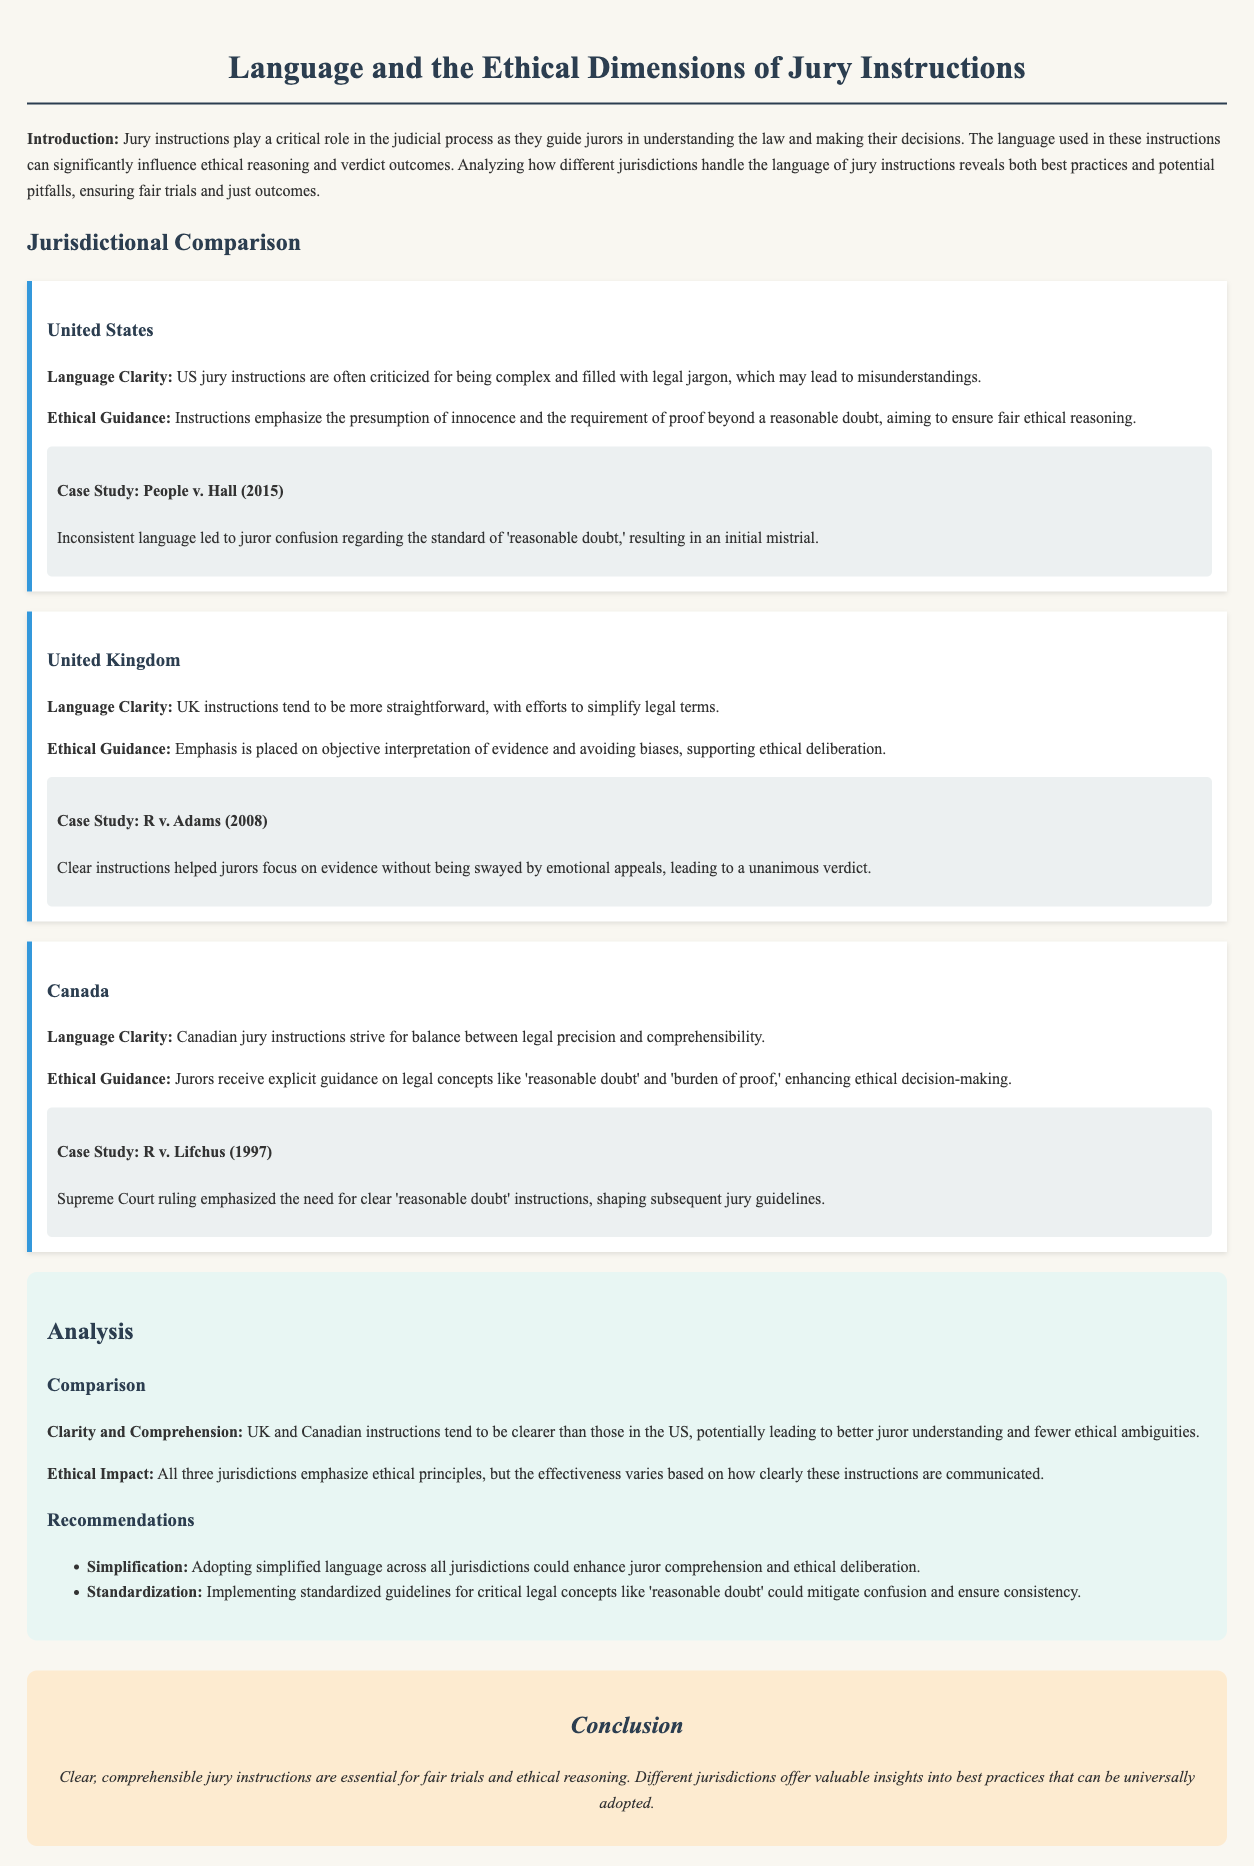what is the primary focus of the document? The document focuses on the influence of language on ethical reasoning through jury instructions across different jurisdictions.
Answer: influence of language on ethical reasoning which case study is related to the United States? The case study that addresses the United States is about People v. Hall in 2015.
Answer: People v. Hall (2015) how do UK jury instructions differ from US instructions in terms of language? UK jury instructions tend to be more straightforward and attempt to simplify legal terms compared to US instructions, which are often complex.
Answer: more straightforward what guidance do Canadian jury instructions provide regarding 'reasonable doubt'? Canadian jury instructions provide explicit guidance on the concept of 'reasonable doubt' to enhance ethical decision-making.
Answer: explicit guidance which recommendation is suggested for improving jury instructions? One of the recommendations is to adopt simplified language across all jurisdictions to enhance comprehension.
Answer: simplified language how does the clarity of jury instructions affect ethical reasoning? The clarity of jury instructions can lead to better juror understanding and fewer ethical ambiguities, impacting the ethical reasoning process.
Answer: better juror understanding which jurisdiction emphasizes the presumption of innocence in jury instructions? The United States emphasizes the presumption of innocence in its jury instructions.
Answer: United States what year did the R v. Lifchus case occur? The R v. Lifchus case occurred in 1997.
Answer: 1997 